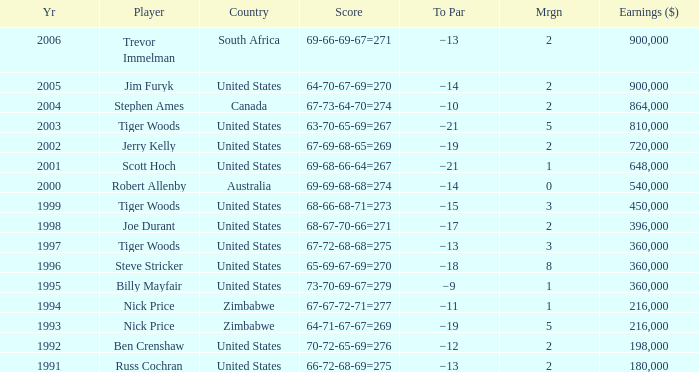How many years have a Player of joe durant, and Earnings ($) larger than 396,000? 0.0. Give me the full table as a dictionary. {'header': ['Yr', 'Player', 'Country', 'Score', 'To Par', 'Mrgn', 'Earnings ($)'], 'rows': [['2006', 'Trevor Immelman', 'South Africa', '69-66-69-67=271', '−13', '2', '900,000'], ['2005', 'Jim Furyk', 'United States', '64-70-67-69=270', '−14', '2', '900,000'], ['2004', 'Stephen Ames', 'Canada', '67-73-64-70=274', '−10', '2', '864,000'], ['2003', 'Tiger Woods', 'United States', '63-70-65-69=267', '−21', '5', '810,000'], ['2002', 'Jerry Kelly', 'United States', '67-69-68-65=269', '−19', '2', '720,000'], ['2001', 'Scott Hoch', 'United States', '69-68-66-64=267', '−21', '1', '648,000'], ['2000', 'Robert Allenby', 'Australia', '69-69-68-68=274', '−14', '0', '540,000'], ['1999', 'Tiger Woods', 'United States', '68-66-68-71=273', '−15', '3', '450,000'], ['1998', 'Joe Durant', 'United States', '68-67-70-66=271', '−17', '2', '396,000'], ['1997', 'Tiger Woods', 'United States', '67-72-68-68=275', '−13', '3', '360,000'], ['1996', 'Steve Stricker', 'United States', '65-69-67-69=270', '−18', '8', '360,000'], ['1995', 'Billy Mayfair', 'United States', '73-70-69-67=279', '−9', '1', '360,000'], ['1994', 'Nick Price', 'Zimbabwe', '67-67-72-71=277', '−11', '1', '216,000'], ['1993', 'Nick Price', 'Zimbabwe', '64-71-67-67=269', '−19', '5', '216,000'], ['1992', 'Ben Crenshaw', 'United States', '70-72-65-69=276', '−12', '2', '198,000'], ['1991', 'Russ Cochran', 'United States', '66-72-68-69=275', '−13', '2', '180,000']]} 